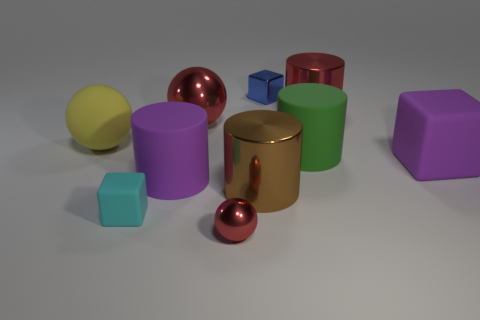What shape is the purple object that is to the right of the red object that is in front of the cyan rubber thing?
Your response must be concise. Cube. How big is the blue cube?
Your response must be concise. Small. What is the shape of the tiny cyan matte thing?
Your response must be concise. Cube. Does the yellow object have the same shape as the big object to the right of the big red cylinder?
Provide a succinct answer. No. Do the metallic object on the right side of the tiny blue metal block and the green matte object have the same shape?
Make the answer very short. Yes. How many objects are both in front of the blue metal thing and right of the large yellow sphere?
Ensure brevity in your answer.  8. How many other things are the same size as the cyan object?
Your response must be concise. 2. Is the number of red shiny objects that are behind the yellow matte object the same as the number of large blue matte cylinders?
Make the answer very short. No. There is a small block that is in front of the big purple rubber cube; does it have the same color as the cube behind the yellow rubber sphere?
Offer a very short reply. No. The thing that is in front of the large brown cylinder and left of the small red ball is made of what material?
Ensure brevity in your answer.  Rubber. 